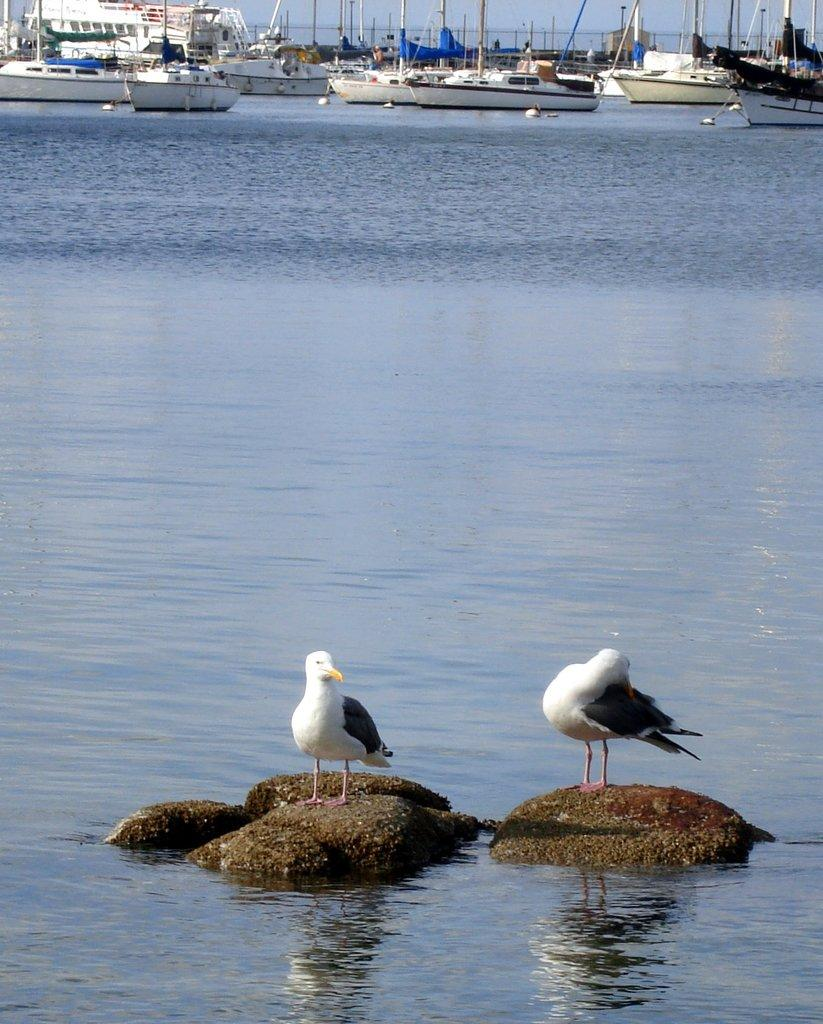What type of natural feature is present in the image? There is a water body in the image. What can be seen in the foreground of the image? There are birds and stones in the foreground of the image. What can be seen in the background of the image? There are boats in the background of the image. What is the limit of the throat in the image? There is no reference to a throat in the image, so it's not possible to determine any limits related to it. 